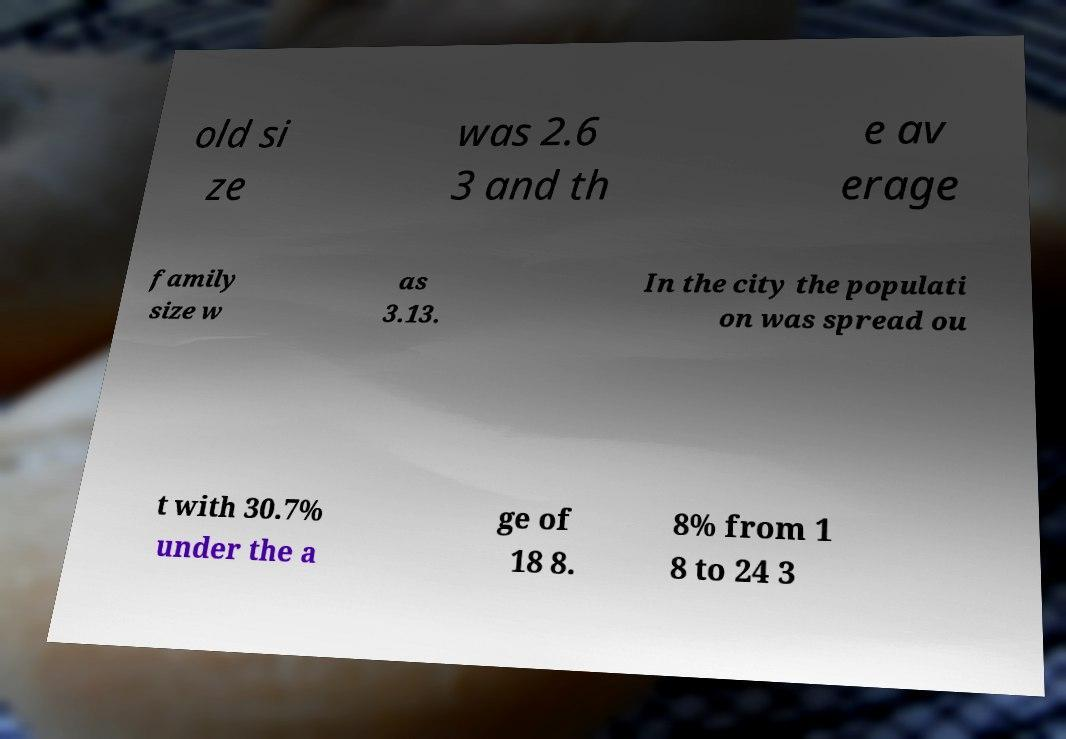What messages or text are displayed in this image? I need them in a readable, typed format. old si ze was 2.6 3 and th e av erage family size w as 3.13. In the city the populati on was spread ou t with 30.7% under the a ge of 18 8. 8% from 1 8 to 24 3 